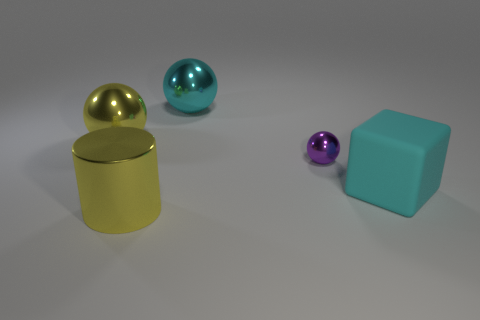Add 3 cyan matte blocks. How many objects exist? 8 Subtract all spheres. How many objects are left? 2 Add 3 tiny red matte cylinders. How many tiny red matte cylinders exist? 3 Subtract 0 yellow cubes. How many objects are left? 5 Subtract all spheres. Subtract all big yellow cubes. How many objects are left? 2 Add 5 rubber objects. How many rubber objects are left? 6 